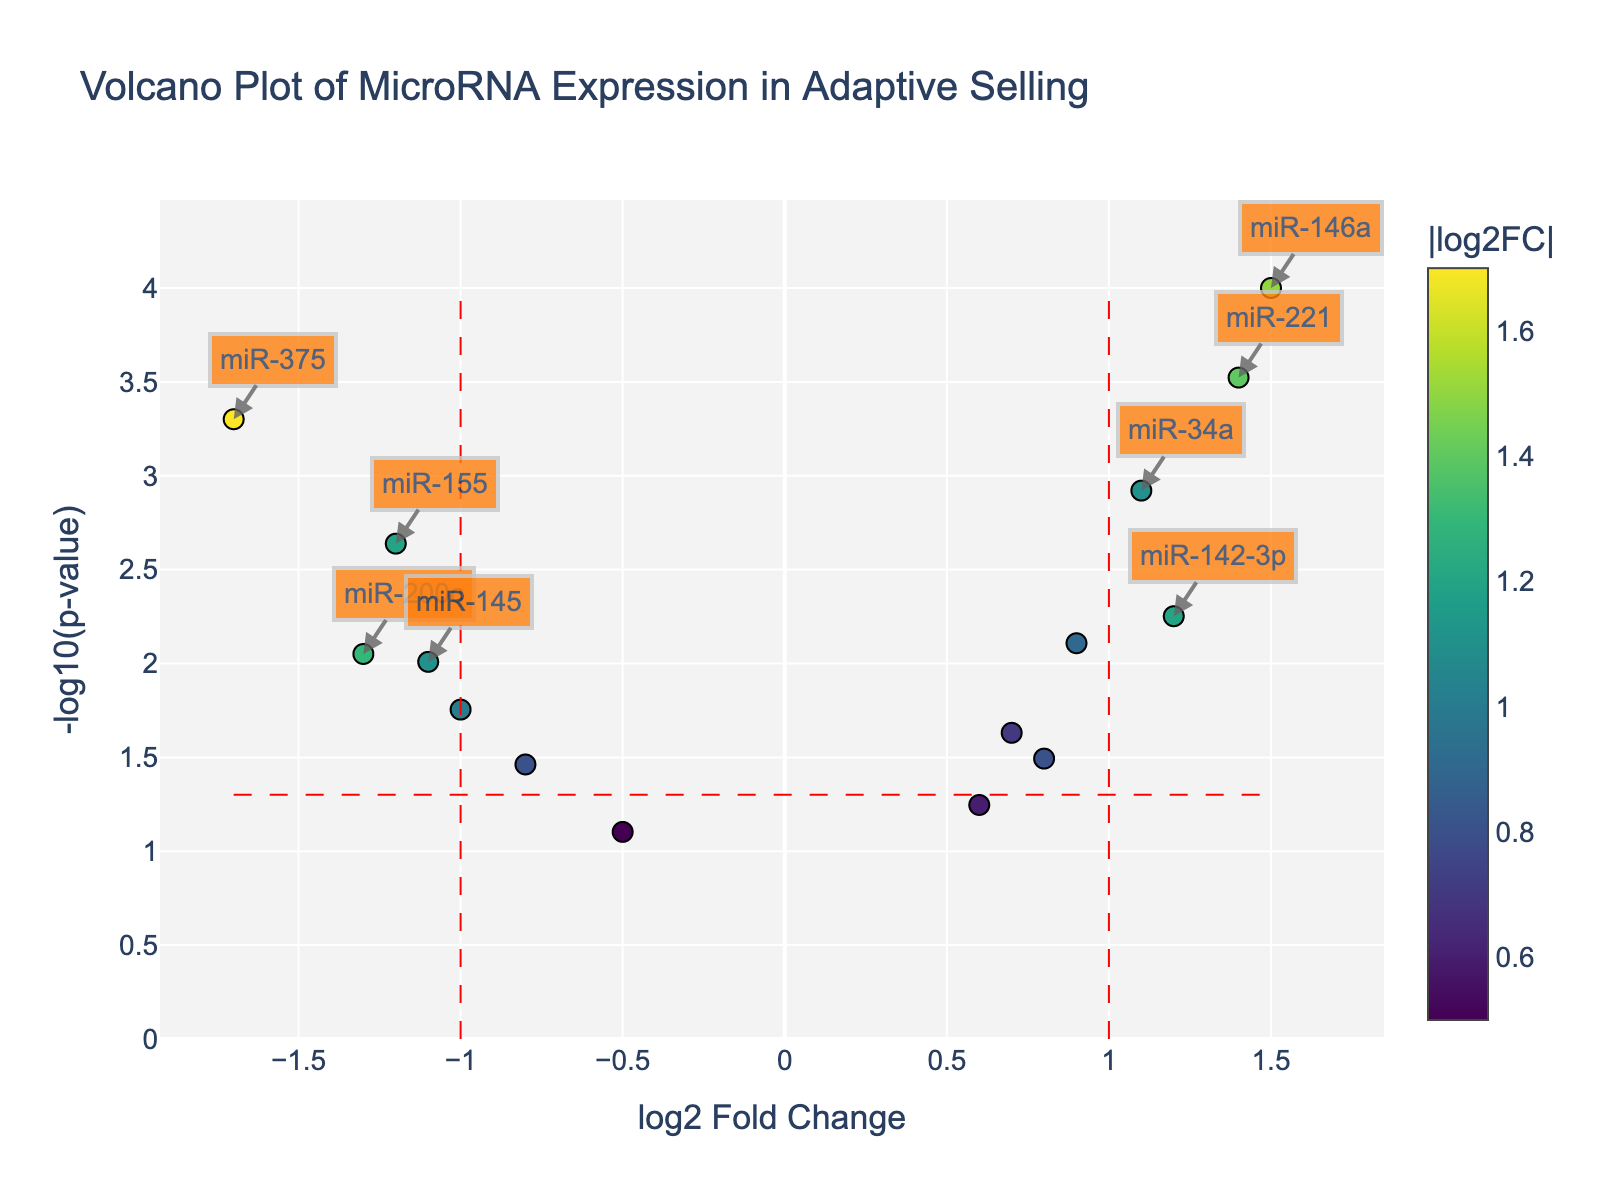How many miRNAs are analyzed in this volcano plot? Count the number of data points (miRNAs) shown on the plot.
Answer: 15 What is the significance threshold for the p-value? Look at the red dashed line along the y-axis; it is at -log10(0.05), which represents the significance threshold.
Answer: 0.05 Which miRNA has the highest log2 fold change? Identify the miRNA data point farthest to the right on the x-axis.
Answer: miR-146a How many miRNAs have a log2 fold change greater than 1? Count the number of data points to the right of the red dashed line at log2FoldChange = 1.
Answer: 4 Which miRNA has the lowest p-value? Find the miRNA data point that is highest on the y-axis.
Answer: miR-146a What is the log2 fold change for miR-21? Locate the 'miR-21' annotation and read its position on the x-axis.
Answer: 0.9 Which miRNAs are considered significant based on both log2 fold change and p-value cutoff? Look for data points beyond the red dashed lines at log2FoldChange > 1 or < -1, and above the red dashed line at -log10(0.05) on the y-axis.
Answer: miR-146a, miR-34a, miR-221, miR-375 What range of log2 fold change allows the miRNAs to be considered as neither significantly upregulated nor downregulated? Identify the range between the two red dashed lines at log2FoldChange = 1 and -1.
Answer: Between -1 and 1 Which miRNA has a more significant p-value, miR-29b or miR-200c? Compare the y-positions (heights) of the dots representing miR-29b and miR-200c.
Answer: miR-200c How many miRNAs have a log2 fold change less than -1 and an associated p-value below 0.05? Count the data points to the left of the red dashed line at log2FoldChange = -1 that are above the red dashed line representing -log10(0.05).
Answer: 4 